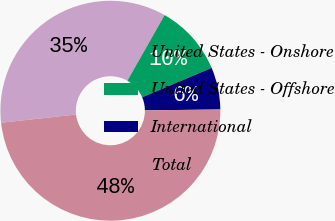Convert chart to OTSL. <chart><loc_0><loc_0><loc_500><loc_500><pie_chart><fcel>United States - Onshore<fcel>United States - Offshore<fcel>International<fcel>Total<nl><fcel>34.95%<fcel>10.42%<fcel>6.19%<fcel>48.44%<nl></chart> 